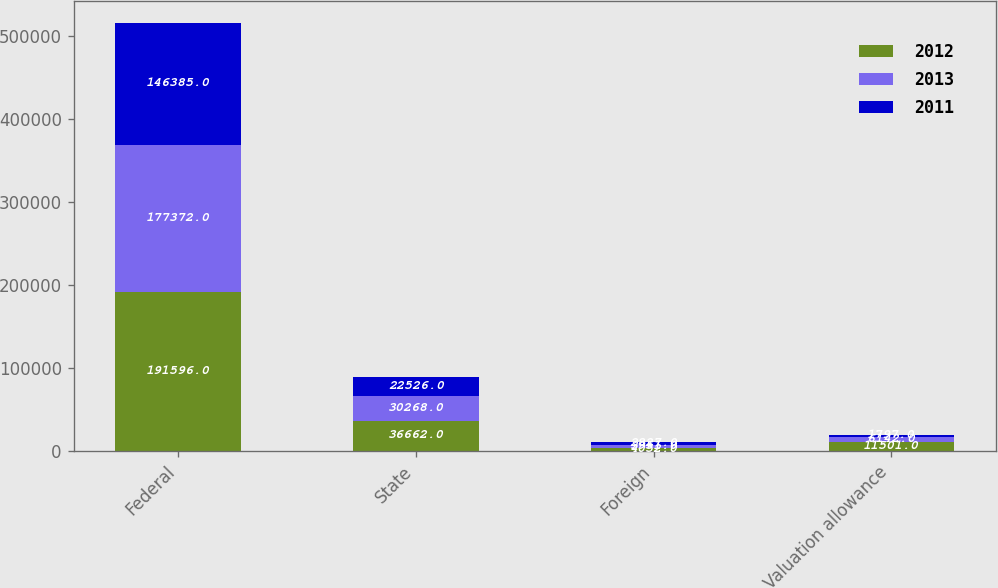<chart> <loc_0><loc_0><loc_500><loc_500><stacked_bar_chart><ecel><fcel>Federal<fcel>State<fcel>Foreign<fcel>Valuation allowance<nl><fcel>2012<fcel>191596<fcel>36662<fcel>4052<fcel>11501<nl><fcel>2013<fcel>177372<fcel>30268<fcel>3951<fcel>6142<nl><fcel>2011<fcel>146385<fcel>22526<fcel>2827<fcel>1797<nl></chart> 